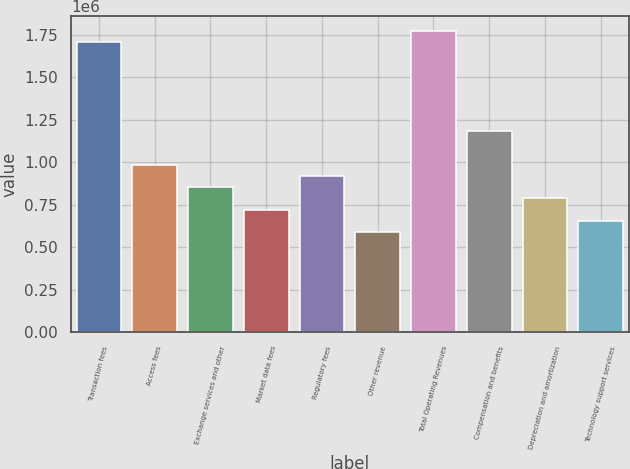Convert chart. <chart><loc_0><loc_0><loc_500><loc_500><bar_chart><fcel>Transaction fees<fcel>Access fees<fcel>Exchange services and other<fcel>Market data fees<fcel>Regulatory fees<fcel>Other revenue<fcel>Total Operating Revenues<fcel>Compensation and benefits<fcel>Depreciation and amortization<fcel>Technology support services<nl><fcel>1.70806e+06<fcel>985418<fcel>854029<fcel>722640<fcel>919723<fcel>591252<fcel>1.77375e+06<fcel>1.1825e+06<fcel>788335<fcel>656946<nl></chart> 